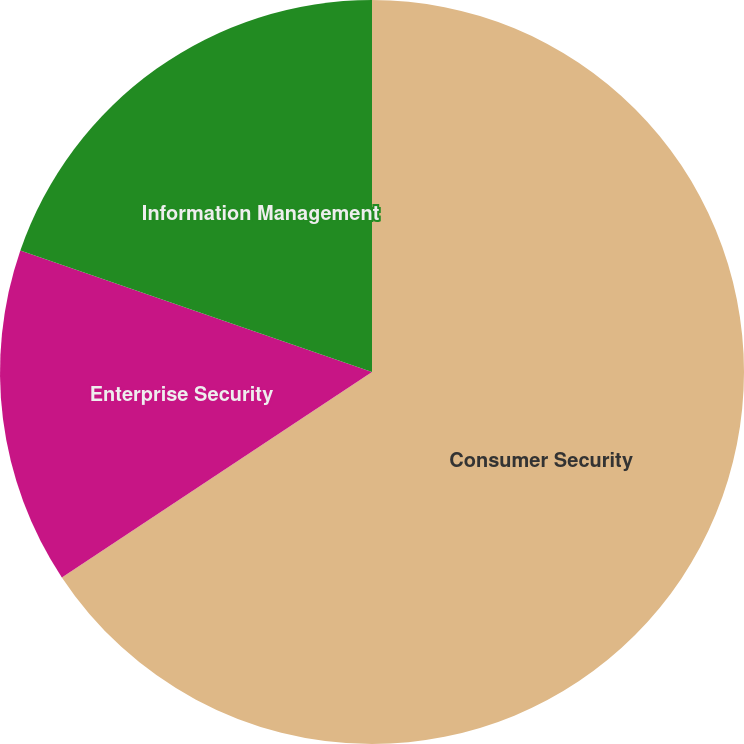Convert chart. <chart><loc_0><loc_0><loc_500><loc_500><pie_chart><fcel>Consumer Security<fcel>Enterprise Security<fcel>Information Management<nl><fcel>65.69%<fcel>14.6%<fcel>19.71%<nl></chart> 